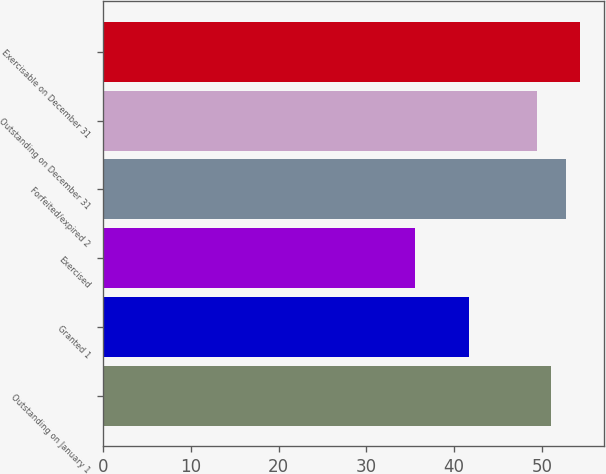<chart> <loc_0><loc_0><loc_500><loc_500><bar_chart><fcel>Outstanding on January 1<fcel>Granted 1<fcel>Exercised<fcel>Forfeited/expired 2<fcel>Outstanding on December 31<fcel>Exercisable on December 31<nl><fcel>51.06<fcel>41.63<fcel>35.54<fcel>52.71<fcel>49.41<fcel>54.36<nl></chart> 